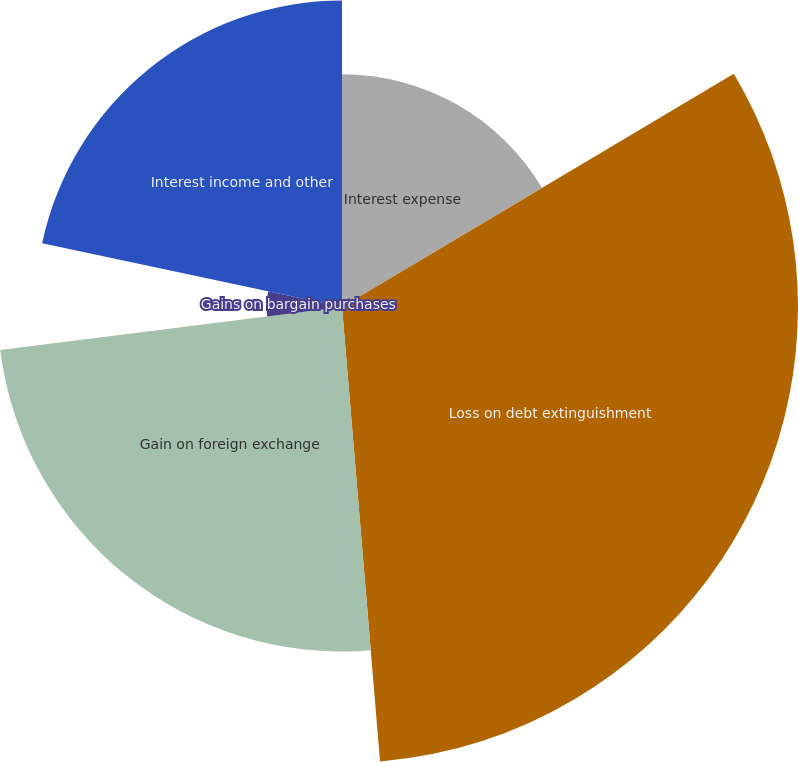Convert chart. <chart><loc_0><loc_0><loc_500><loc_500><pie_chart><fcel>Interest expense<fcel>Loss on debt extinguishment<fcel>Gain on foreign exchange<fcel>Gains on bargain purchases<fcel>Interest income and other<nl><fcel>16.45%<fcel>32.22%<fcel>24.34%<fcel>5.33%<fcel>21.66%<nl></chart> 